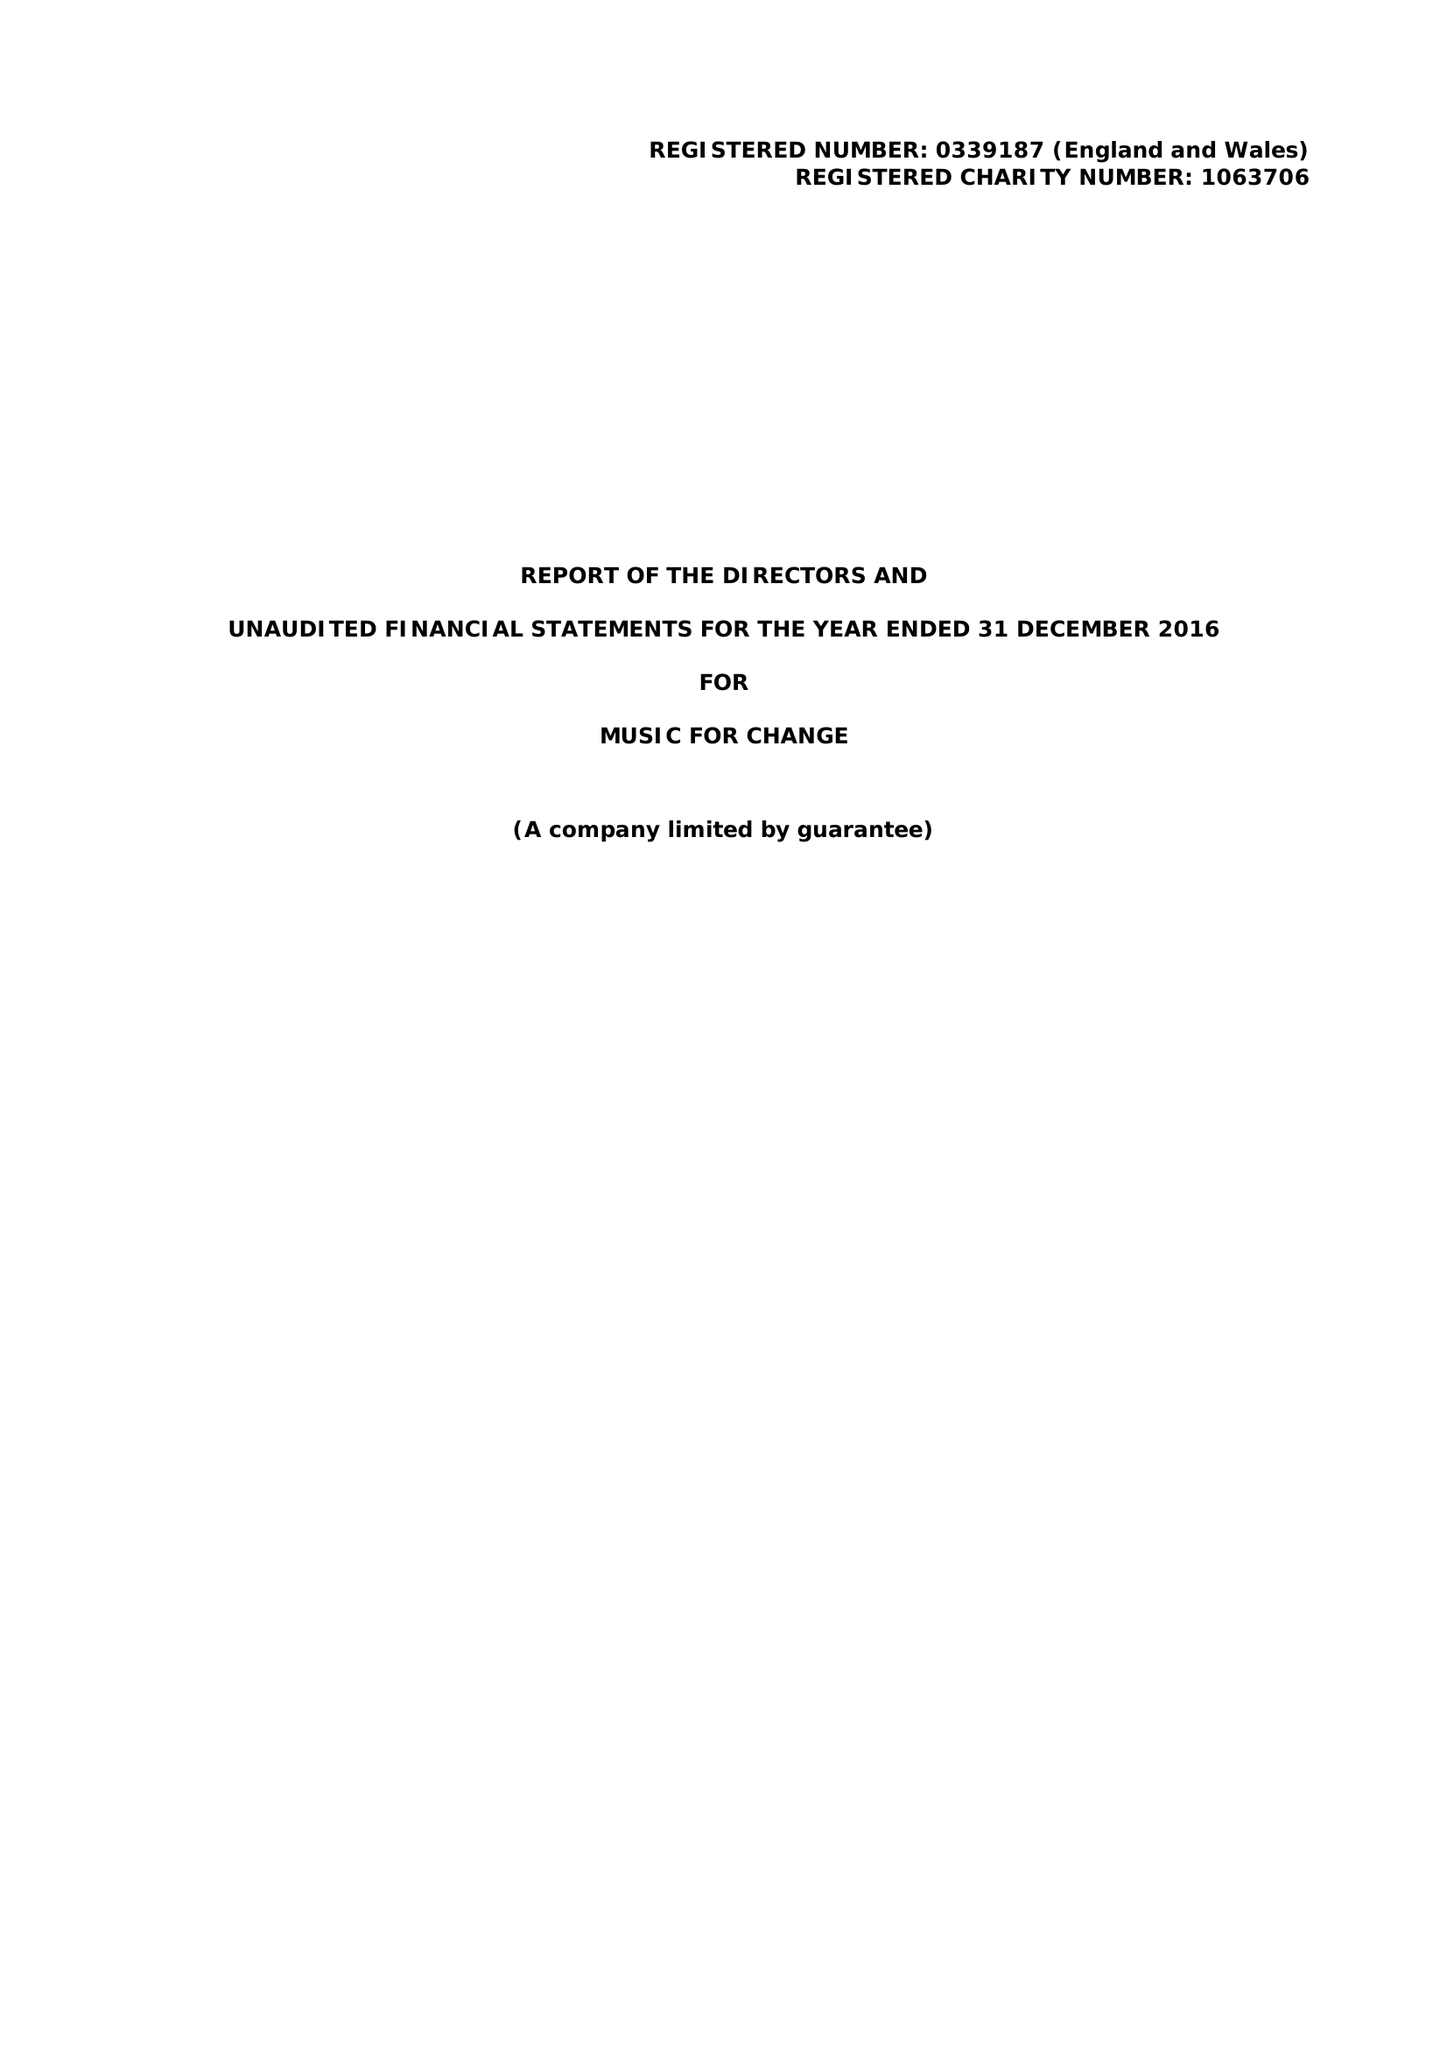What is the value for the address__street_line?
Answer the question using a single word or phrase. 77 STOUR STREET 